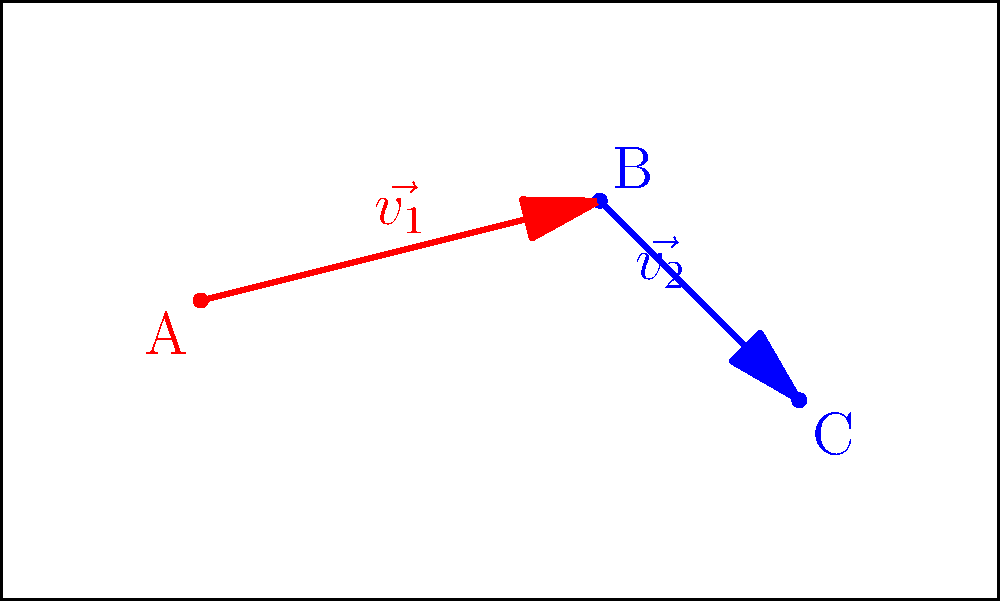In the diagram above, player A (attacker) attempts to pass the ball to player B, who then aims to pass to player C. The probability of a successful pass is inversely proportional to the square of the distance between players. If the probability of a successful pass from A to B is 0.8, and the field dimensions are 100x60 meters, calculate the probability of both passes (A to B, then B to C) being successful. Round your answer to three decimal places. Let's approach this step-by-step:

1) First, we need to calculate the distances between the players. We can do this using the Pythagorean theorem.

   Distance AB = $\sqrt{(60-20)^2 + (40-30)^2} = \sqrt{1600 + 100} = \sqrt{1700} \approx 41.23$ meters
   Distance BC = $\sqrt{(80-60)^2 + (20-40)^2} = \sqrt{400 + 400} = \sqrt{800} \approx 28.28$ meters

2) We're given that the probability of a successful pass from A to B is 0.8. Let's call the constant of proportionality $k$. Then:

   $0.8 = \frac{k}{41.23^2}$

3) Solving for $k$:

   $k = 0.8 * 41.23^2 = 1360.76$

4) Now we can calculate the probability of a successful pass from B to C:

   $P(B \text{ to } C) = \frac{1360.76}{28.28^2} \approx 1.70$

   However, probability cannot exceed 1, so we cap this at 1.

5) The probability of both passes being successful is the product of the individual probabilities:

   $P(\text{both successful}) = 0.8 * 1 = 0.8$

6) Rounding to three decimal places:

   $0.800$
Answer: 0.800 